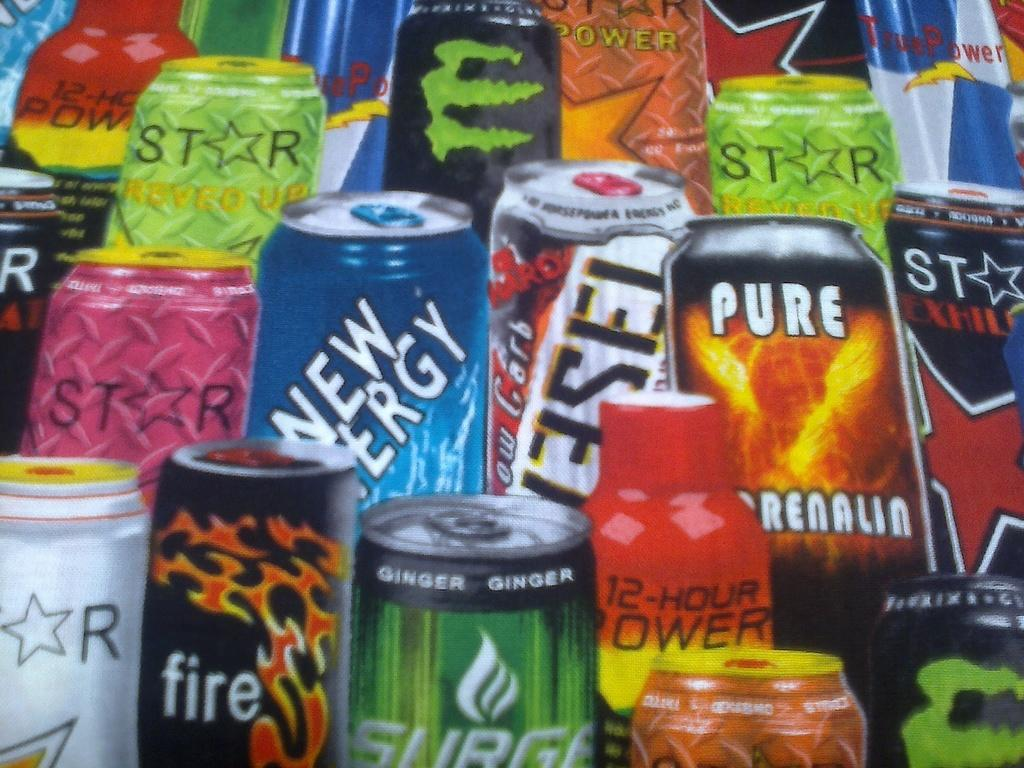<image>
Summarize the visual content of the image. the word pure that is on the can of an item 